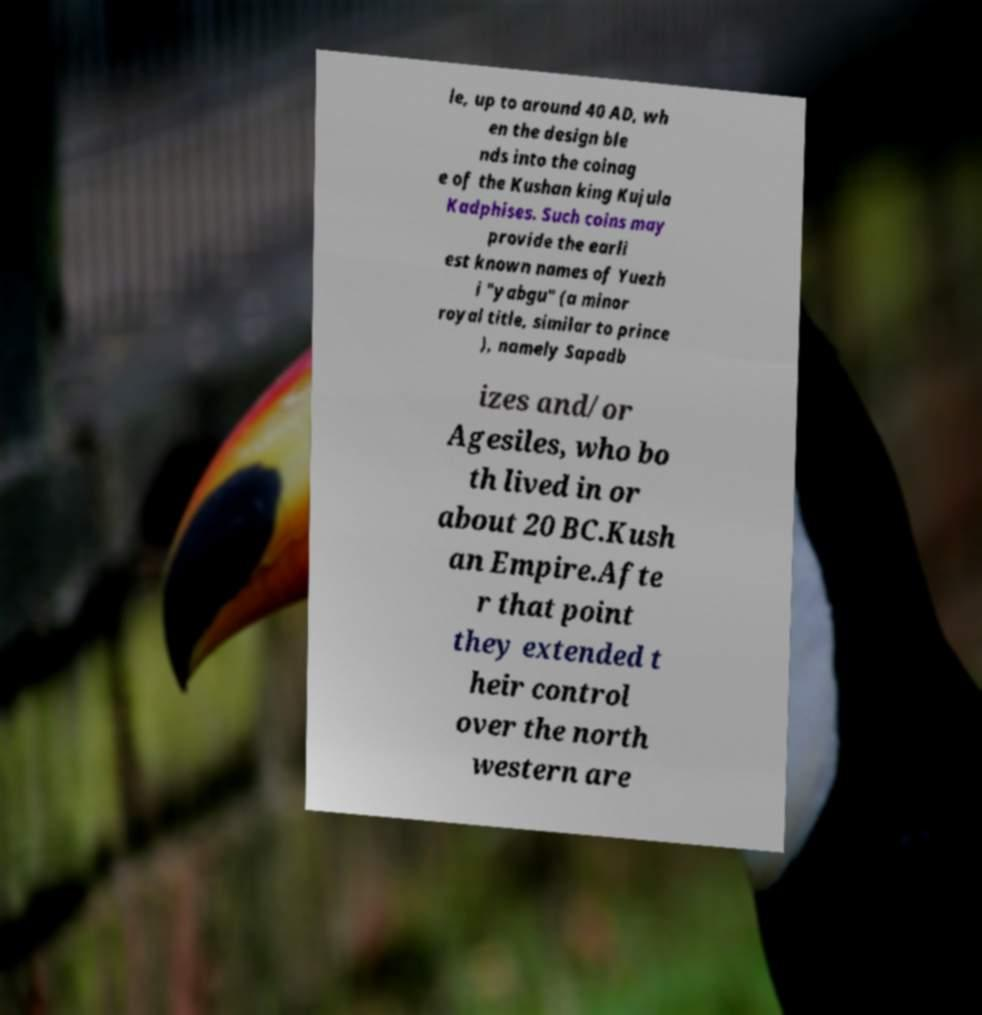Please identify and transcribe the text found in this image. le, up to around 40 AD, wh en the design ble nds into the coinag e of the Kushan king Kujula Kadphises. Such coins may provide the earli est known names of Yuezh i "yabgu" (a minor royal title, similar to prince ), namely Sapadb izes and/or Agesiles, who bo th lived in or about 20 BC.Kush an Empire.Afte r that point they extended t heir control over the north western are 